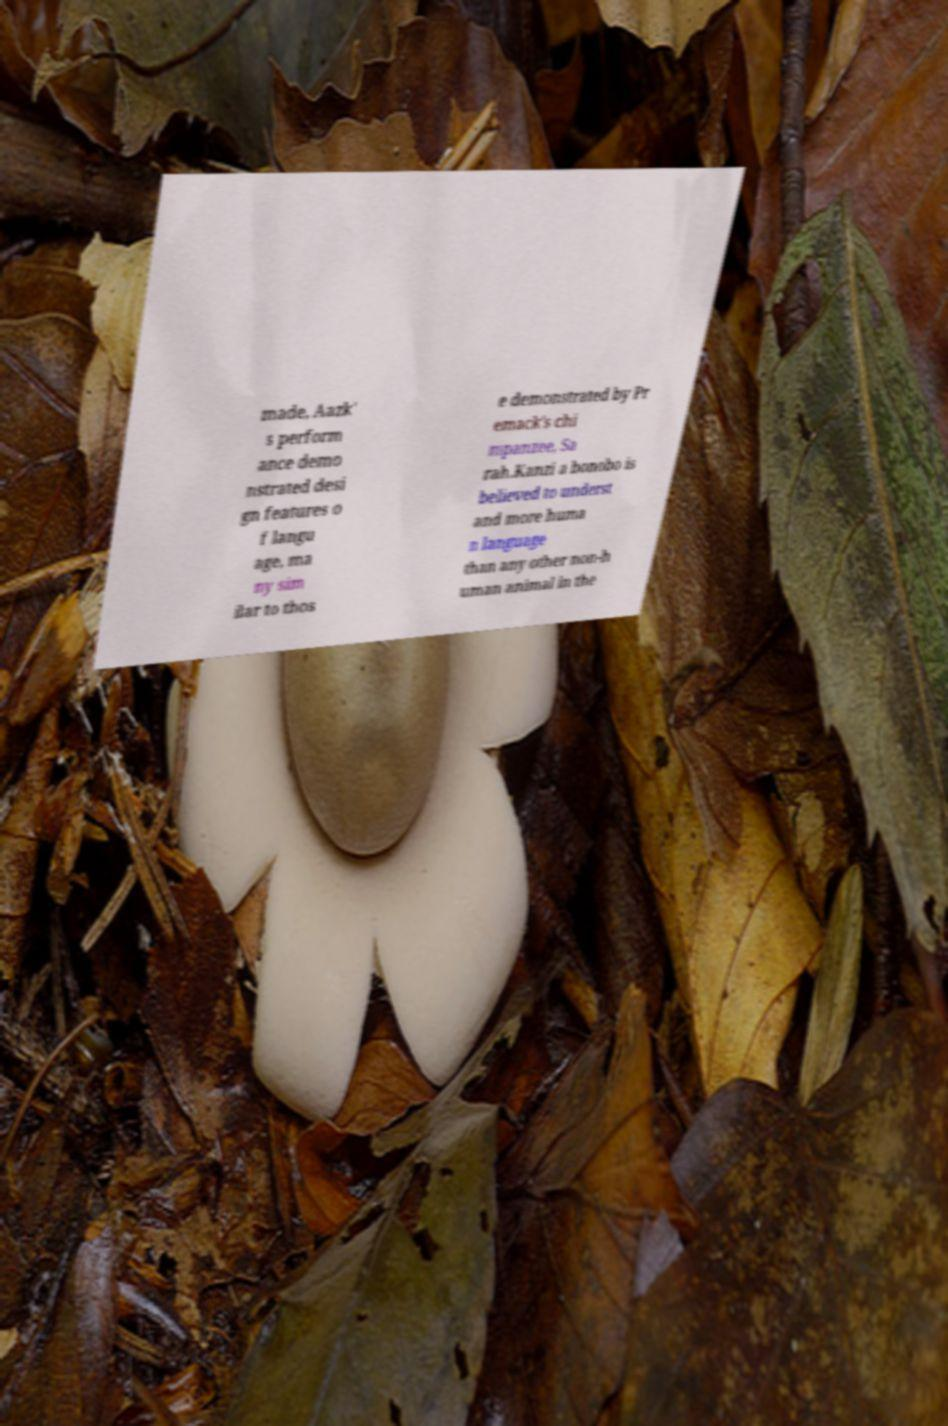I need the written content from this picture converted into text. Can you do that? made, Aazk' s perform ance demo nstrated desi gn features o f langu age, ma ny sim ilar to thos e demonstrated by Pr emack's chi mpanzee, Sa rah.Kanzi a bonobo is believed to underst and more huma n language than any other non-h uman animal in the 